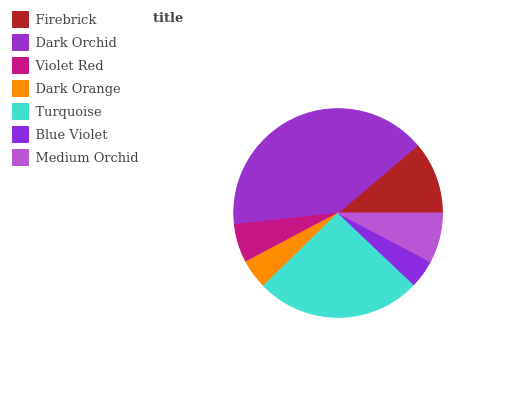Is Blue Violet the minimum?
Answer yes or no. Yes. Is Dark Orchid the maximum?
Answer yes or no. Yes. Is Violet Red the minimum?
Answer yes or no. No. Is Violet Red the maximum?
Answer yes or no. No. Is Dark Orchid greater than Violet Red?
Answer yes or no. Yes. Is Violet Red less than Dark Orchid?
Answer yes or no. Yes. Is Violet Red greater than Dark Orchid?
Answer yes or no. No. Is Dark Orchid less than Violet Red?
Answer yes or no. No. Is Medium Orchid the high median?
Answer yes or no. Yes. Is Medium Orchid the low median?
Answer yes or no. Yes. Is Dark Orange the high median?
Answer yes or no. No. Is Firebrick the low median?
Answer yes or no. No. 